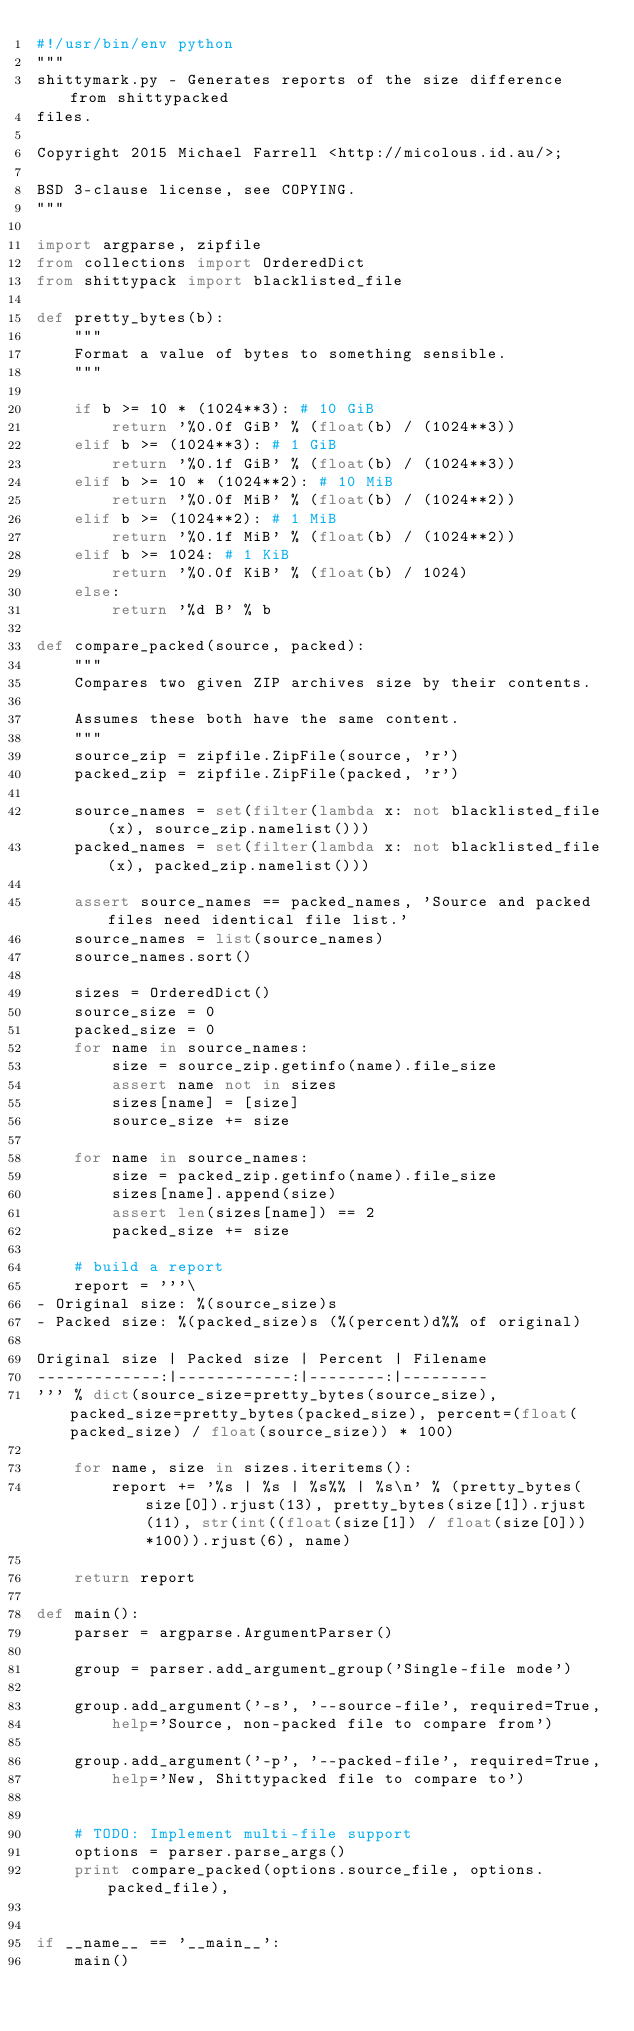<code> <loc_0><loc_0><loc_500><loc_500><_Python_>#!/usr/bin/env python
"""
shittymark.py - Generates reports of the size difference from shittypacked
files.

Copyright 2015 Michael Farrell <http://micolous.id.au/>;

BSD 3-clause license, see COPYING.
"""

import argparse, zipfile
from collections import OrderedDict
from shittypack import blacklisted_file

def pretty_bytes(b):
	"""
	Format a value of bytes to something sensible.
	"""

	if b >= 10 * (1024**3): # 10 GiB
		return '%0.0f GiB' % (float(b) / (1024**3))
	elif b >= (1024**3): # 1 GiB
		return '%0.1f GiB' % (float(b) / (1024**3))
	elif b >= 10 * (1024**2): # 10 MiB
		return '%0.0f MiB' % (float(b) / (1024**2))
	elif b >= (1024**2): # 1 MiB
		return '%0.1f MiB' % (float(b) / (1024**2))
	elif b >= 1024: # 1 KiB
		return '%0.0f KiB' % (float(b) / 1024)
	else:
		return '%d B' % b

def compare_packed(source, packed):
	"""
	Compares two given ZIP archives size by their contents.

	Assumes these both have the same content.
	"""
	source_zip = zipfile.ZipFile(source, 'r')
	packed_zip = zipfile.ZipFile(packed, 'r')

	source_names = set(filter(lambda x: not blacklisted_file(x), source_zip.namelist()))
	packed_names = set(filter(lambda x: not blacklisted_file(x), packed_zip.namelist()))

	assert source_names == packed_names, 'Source and packed files need identical file list.'
	source_names = list(source_names)
	source_names.sort()

	sizes = OrderedDict()
	source_size = 0
	packed_size = 0
	for name in source_names:
		size = source_zip.getinfo(name).file_size
		assert name not in sizes
		sizes[name] = [size]
		source_size += size

	for name in source_names:
		size = packed_zip.getinfo(name).file_size
		sizes[name].append(size)
		assert len(sizes[name]) == 2
		packed_size += size

	# build a report
	report = '''\
- Original size: %(source_size)s
- Packed size: %(packed_size)s (%(percent)d%% of original)

Original size | Packed size | Percent | Filename
-------------:|------------:|--------:|---------
''' % dict(source_size=pretty_bytes(source_size), packed_size=pretty_bytes(packed_size), percent=(float(packed_size) / float(source_size)) * 100)

	for name, size in sizes.iteritems():
		report += '%s | %s | %s%% | %s\n' % (pretty_bytes(size[0]).rjust(13), pretty_bytes(size[1]).rjust(11), str(int((float(size[1]) / float(size[0]))*100)).rjust(6), name)

	return report

def main():
	parser = argparse.ArgumentParser()

	group = parser.add_argument_group('Single-file mode')

	group.add_argument('-s', '--source-file', required=True,
		help='Source, non-packed file to compare from')

	group.add_argument('-p', '--packed-file', required=True,
		help='New, Shittypacked file to compare to')


	# TODO: Implement multi-file support
	options = parser.parse_args()
	print compare_packed(options.source_file, options.packed_file),


if __name__ == '__main__':
	main()

</code> 